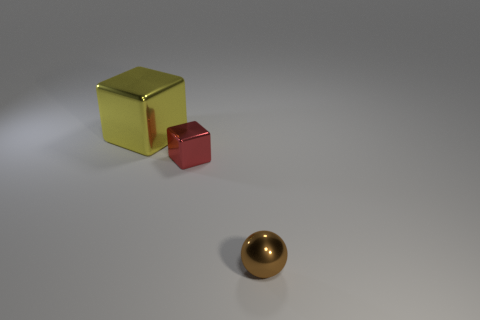Add 3 tiny blocks. How many objects exist? 6 Subtract all cubes. How many objects are left? 1 Subtract all brown shiny objects. Subtract all brown metallic objects. How many objects are left? 1 Add 3 metal things. How many metal things are left? 6 Add 3 shiny things. How many shiny things exist? 6 Subtract 0 green blocks. How many objects are left? 3 